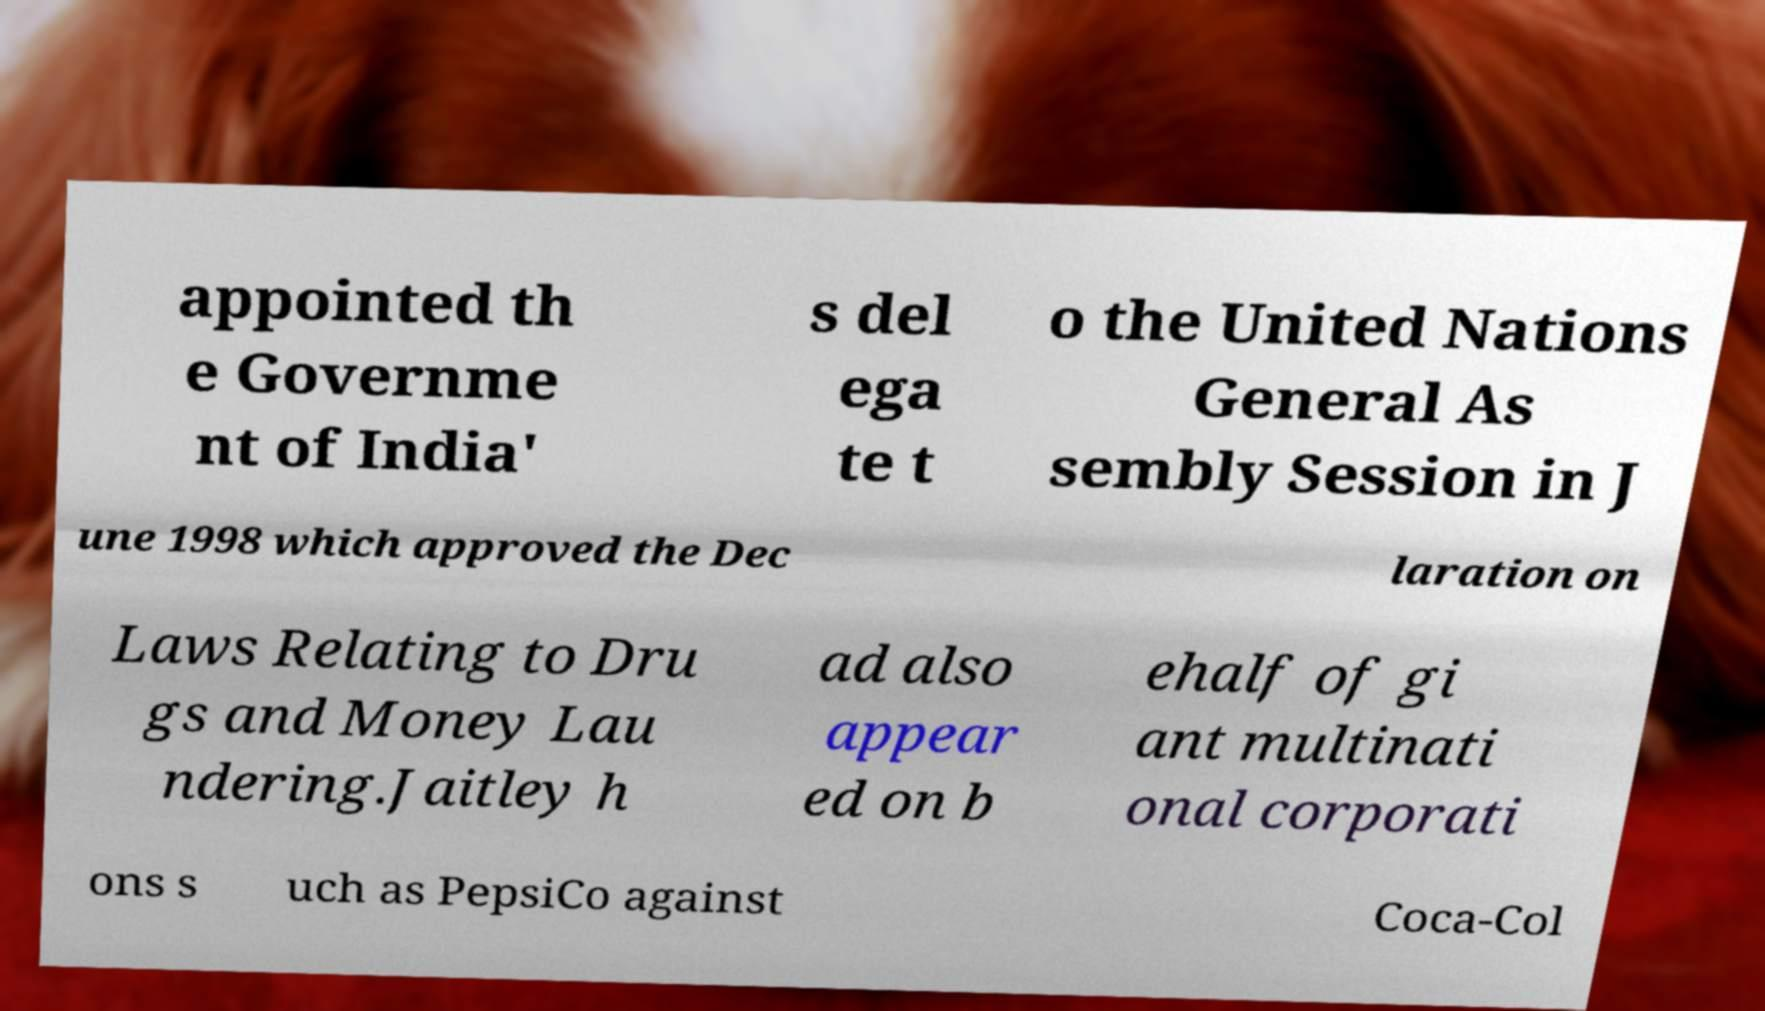There's text embedded in this image that I need extracted. Can you transcribe it verbatim? appointed th e Governme nt of India' s del ega te t o the United Nations General As sembly Session in J une 1998 which approved the Dec laration on Laws Relating to Dru gs and Money Lau ndering.Jaitley h ad also appear ed on b ehalf of gi ant multinati onal corporati ons s uch as PepsiCo against Coca-Col 